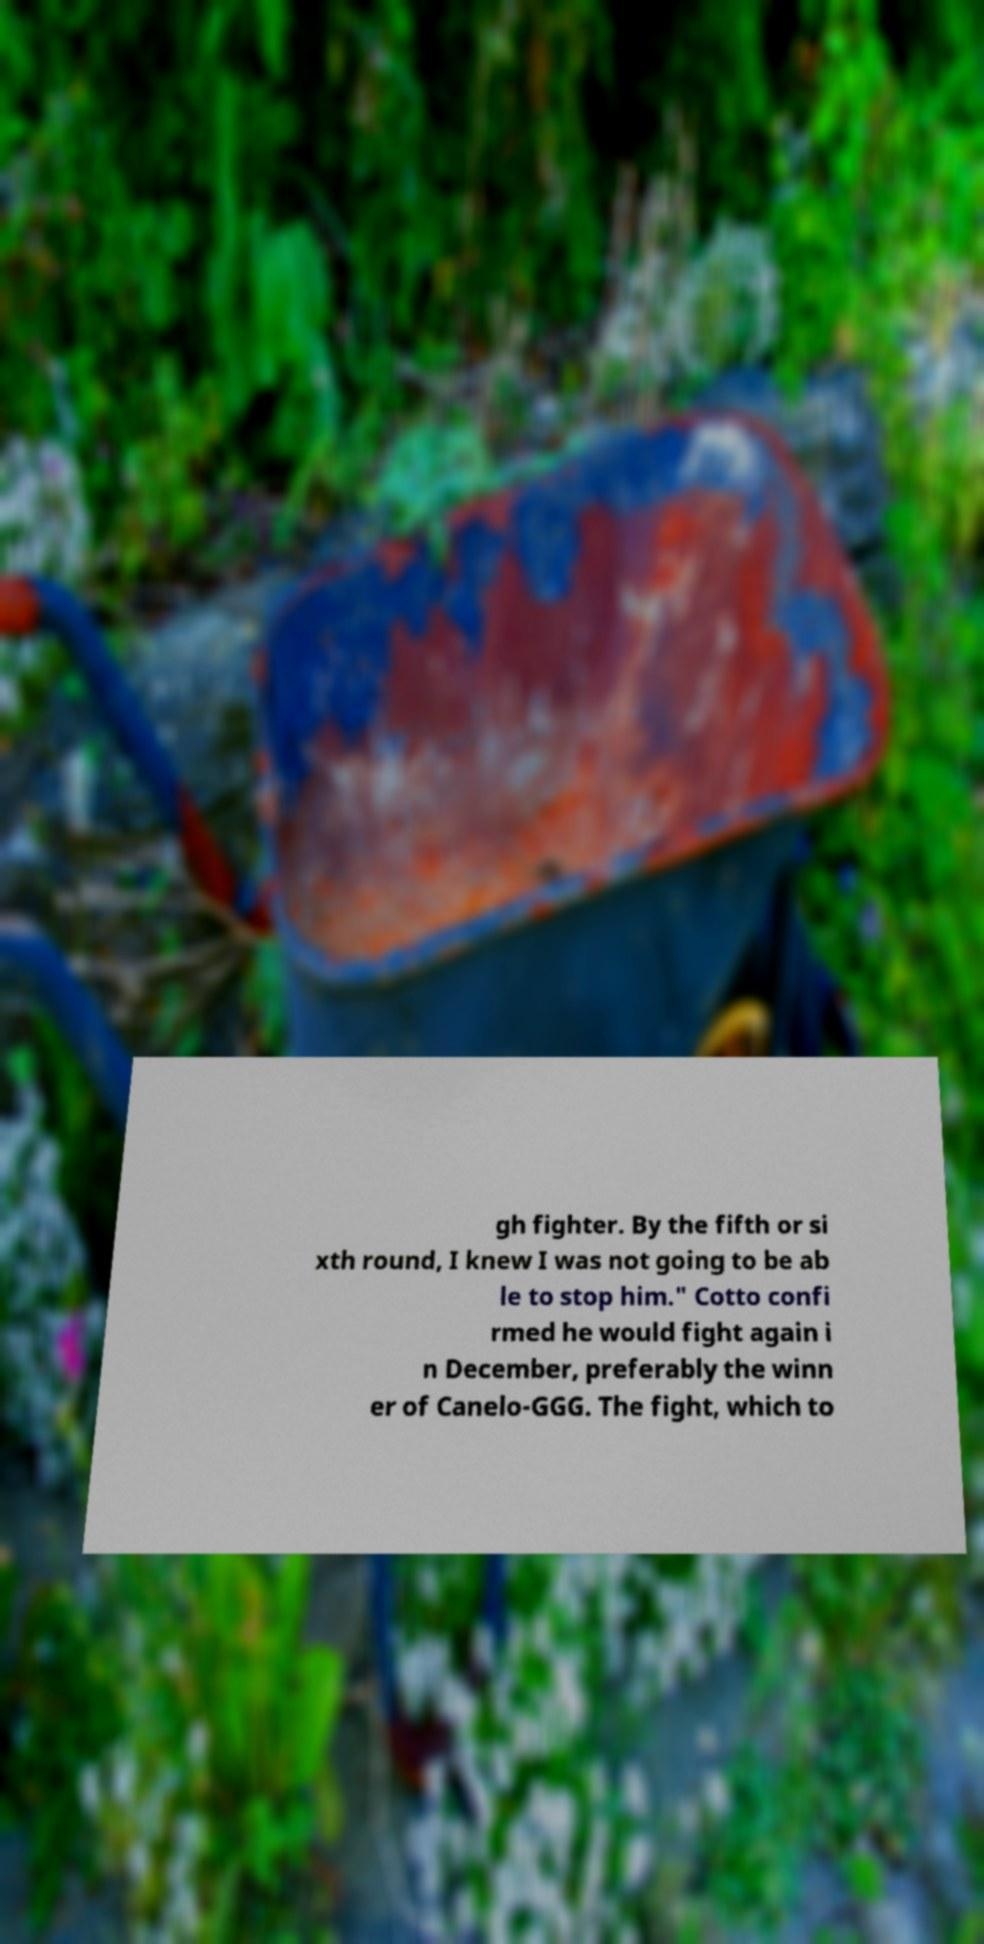Can you read and provide the text displayed in the image?This photo seems to have some interesting text. Can you extract and type it out for me? gh fighter. By the fifth or si xth round, I knew I was not going to be ab le to stop him." Cotto confi rmed he would fight again i n December, preferably the winn er of Canelo-GGG. The fight, which to 